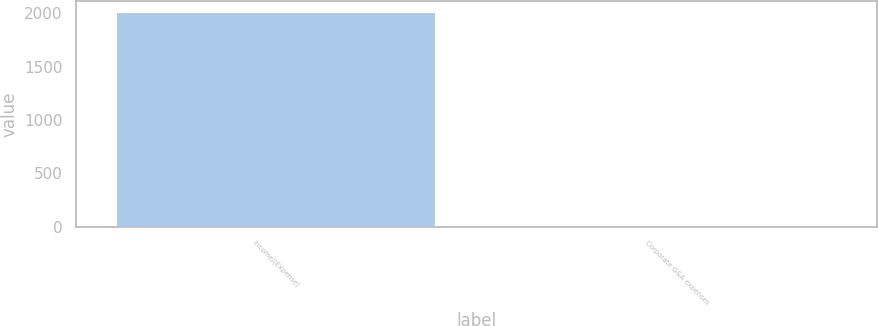Convert chart. <chart><loc_0><loc_0><loc_500><loc_500><bar_chart><fcel>Income/(Expense)<fcel>Corporate G&A expenses<nl><fcel>2015<fcel>3<nl></chart> 